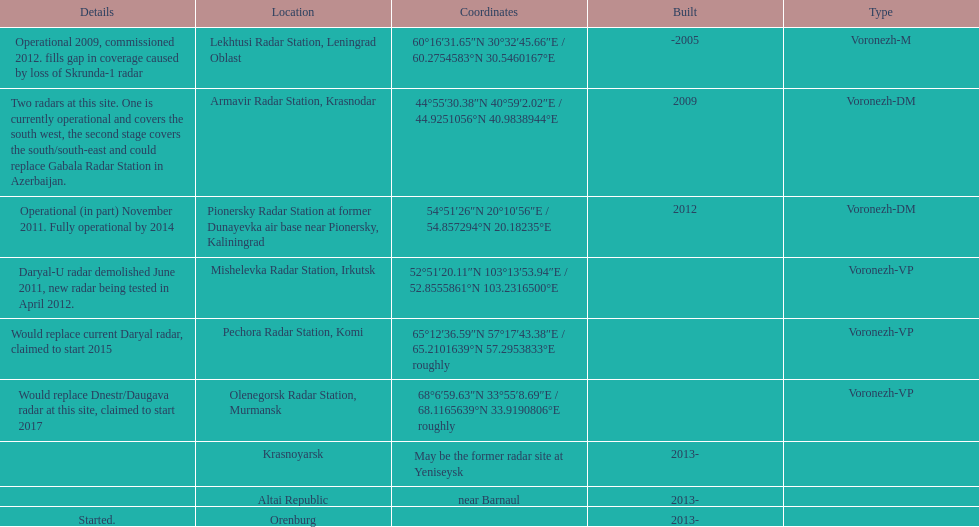What is the only radar that will start in 2015? Pechora Radar Station, Komi. 